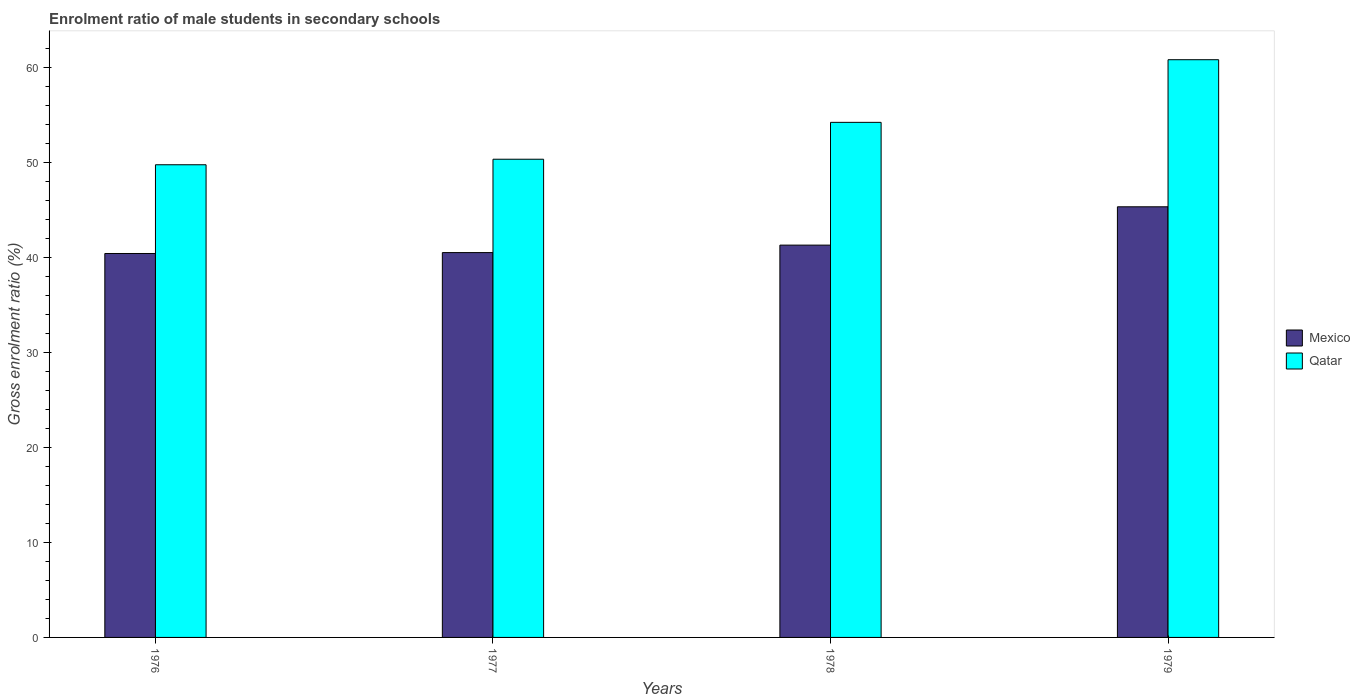How many different coloured bars are there?
Provide a succinct answer. 2. How many groups of bars are there?
Provide a short and direct response. 4. Are the number of bars on each tick of the X-axis equal?
Give a very brief answer. Yes. How many bars are there on the 2nd tick from the left?
Your answer should be very brief. 2. How many bars are there on the 3rd tick from the right?
Offer a terse response. 2. What is the label of the 2nd group of bars from the left?
Give a very brief answer. 1977. In how many cases, is the number of bars for a given year not equal to the number of legend labels?
Provide a succinct answer. 0. What is the enrolment ratio of male students in secondary schools in Qatar in 1976?
Provide a short and direct response. 49.75. Across all years, what is the maximum enrolment ratio of male students in secondary schools in Qatar?
Ensure brevity in your answer.  60.81. Across all years, what is the minimum enrolment ratio of male students in secondary schools in Qatar?
Keep it short and to the point. 49.75. In which year was the enrolment ratio of male students in secondary schools in Mexico maximum?
Ensure brevity in your answer.  1979. In which year was the enrolment ratio of male students in secondary schools in Mexico minimum?
Provide a short and direct response. 1976. What is the total enrolment ratio of male students in secondary schools in Mexico in the graph?
Your response must be concise. 167.54. What is the difference between the enrolment ratio of male students in secondary schools in Qatar in 1976 and that in 1977?
Give a very brief answer. -0.58. What is the difference between the enrolment ratio of male students in secondary schools in Mexico in 1978 and the enrolment ratio of male students in secondary schools in Qatar in 1979?
Make the answer very short. -19.52. What is the average enrolment ratio of male students in secondary schools in Mexico per year?
Offer a very short reply. 41.88. In the year 1979, what is the difference between the enrolment ratio of male students in secondary schools in Mexico and enrolment ratio of male students in secondary schools in Qatar?
Your response must be concise. -15.48. In how many years, is the enrolment ratio of male students in secondary schools in Mexico greater than 40 %?
Offer a terse response. 4. What is the ratio of the enrolment ratio of male students in secondary schools in Qatar in 1978 to that in 1979?
Keep it short and to the point. 0.89. Is the difference between the enrolment ratio of male students in secondary schools in Mexico in 1977 and 1978 greater than the difference between the enrolment ratio of male students in secondary schools in Qatar in 1977 and 1978?
Your answer should be very brief. Yes. What is the difference between the highest and the second highest enrolment ratio of male students in secondary schools in Mexico?
Your response must be concise. 4.03. What is the difference between the highest and the lowest enrolment ratio of male students in secondary schools in Qatar?
Keep it short and to the point. 11.06. What does the 2nd bar from the left in 1976 represents?
Offer a terse response. Qatar. What does the 1st bar from the right in 1979 represents?
Make the answer very short. Qatar. How many bars are there?
Your answer should be compact. 8. Does the graph contain any zero values?
Offer a terse response. No. Does the graph contain grids?
Your answer should be very brief. No. How many legend labels are there?
Keep it short and to the point. 2. What is the title of the graph?
Ensure brevity in your answer.  Enrolment ratio of male students in secondary schools. Does "Sub-Saharan Africa (all income levels)" appear as one of the legend labels in the graph?
Your response must be concise. No. What is the label or title of the X-axis?
Offer a terse response. Years. What is the Gross enrolment ratio (%) of Mexico in 1976?
Make the answer very short. 40.41. What is the Gross enrolment ratio (%) in Qatar in 1976?
Offer a very short reply. 49.75. What is the Gross enrolment ratio (%) in Mexico in 1977?
Make the answer very short. 40.51. What is the Gross enrolment ratio (%) in Qatar in 1977?
Make the answer very short. 50.33. What is the Gross enrolment ratio (%) in Mexico in 1978?
Keep it short and to the point. 41.29. What is the Gross enrolment ratio (%) of Qatar in 1978?
Give a very brief answer. 54.21. What is the Gross enrolment ratio (%) of Mexico in 1979?
Make the answer very short. 45.33. What is the Gross enrolment ratio (%) in Qatar in 1979?
Your response must be concise. 60.81. Across all years, what is the maximum Gross enrolment ratio (%) in Mexico?
Your response must be concise. 45.33. Across all years, what is the maximum Gross enrolment ratio (%) of Qatar?
Your answer should be compact. 60.81. Across all years, what is the minimum Gross enrolment ratio (%) of Mexico?
Provide a short and direct response. 40.41. Across all years, what is the minimum Gross enrolment ratio (%) in Qatar?
Provide a succinct answer. 49.75. What is the total Gross enrolment ratio (%) in Mexico in the graph?
Keep it short and to the point. 167.54. What is the total Gross enrolment ratio (%) in Qatar in the graph?
Make the answer very short. 215.11. What is the difference between the Gross enrolment ratio (%) in Mexico in 1976 and that in 1977?
Keep it short and to the point. -0.09. What is the difference between the Gross enrolment ratio (%) in Qatar in 1976 and that in 1977?
Give a very brief answer. -0.58. What is the difference between the Gross enrolment ratio (%) of Mexico in 1976 and that in 1978?
Your response must be concise. -0.88. What is the difference between the Gross enrolment ratio (%) of Qatar in 1976 and that in 1978?
Keep it short and to the point. -4.46. What is the difference between the Gross enrolment ratio (%) in Mexico in 1976 and that in 1979?
Offer a terse response. -4.91. What is the difference between the Gross enrolment ratio (%) in Qatar in 1976 and that in 1979?
Keep it short and to the point. -11.06. What is the difference between the Gross enrolment ratio (%) of Mexico in 1977 and that in 1978?
Offer a terse response. -0.79. What is the difference between the Gross enrolment ratio (%) in Qatar in 1977 and that in 1978?
Your answer should be very brief. -3.88. What is the difference between the Gross enrolment ratio (%) of Mexico in 1977 and that in 1979?
Give a very brief answer. -4.82. What is the difference between the Gross enrolment ratio (%) of Qatar in 1977 and that in 1979?
Make the answer very short. -10.47. What is the difference between the Gross enrolment ratio (%) of Mexico in 1978 and that in 1979?
Ensure brevity in your answer.  -4.03. What is the difference between the Gross enrolment ratio (%) in Qatar in 1978 and that in 1979?
Give a very brief answer. -6.59. What is the difference between the Gross enrolment ratio (%) of Mexico in 1976 and the Gross enrolment ratio (%) of Qatar in 1977?
Offer a very short reply. -9.92. What is the difference between the Gross enrolment ratio (%) of Mexico in 1976 and the Gross enrolment ratio (%) of Qatar in 1978?
Your answer should be compact. -13.8. What is the difference between the Gross enrolment ratio (%) in Mexico in 1976 and the Gross enrolment ratio (%) in Qatar in 1979?
Keep it short and to the point. -20.4. What is the difference between the Gross enrolment ratio (%) in Mexico in 1977 and the Gross enrolment ratio (%) in Qatar in 1978?
Provide a short and direct response. -13.71. What is the difference between the Gross enrolment ratio (%) of Mexico in 1977 and the Gross enrolment ratio (%) of Qatar in 1979?
Give a very brief answer. -20.3. What is the difference between the Gross enrolment ratio (%) in Mexico in 1978 and the Gross enrolment ratio (%) in Qatar in 1979?
Provide a short and direct response. -19.52. What is the average Gross enrolment ratio (%) in Mexico per year?
Your answer should be very brief. 41.88. What is the average Gross enrolment ratio (%) in Qatar per year?
Provide a succinct answer. 53.78. In the year 1976, what is the difference between the Gross enrolment ratio (%) in Mexico and Gross enrolment ratio (%) in Qatar?
Ensure brevity in your answer.  -9.34. In the year 1977, what is the difference between the Gross enrolment ratio (%) in Mexico and Gross enrolment ratio (%) in Qatar?
Make the answer very short. -9.83. In the year 1978, what is the difference between the Gross enrolment ratio (%) of Mexico and Gross enrolment ratio (%) of Qatar?
Make the answer very short. -12.92. In the year 1979, what is the difference between the Gross enrolment ratio (%) in Mexico and Gross enrolment ratio (%) in Qatar?
Make the answer very short. -15.48. What is the ratio of the Gross enrolment ratio (%) of Qatar in 1976 to that in 1977?
Keep it short and to the point. 0.99. What is the ratio of the Gross enrolment ratio (%) in Mexico in 1976 to that in 1978?
Provide a succinct answer. 0.98. What is the ratio of the Gross enrolment ratio (%) in Qatar in 1976 to that in 1978?
Keep it short and to the point. 0.92. What is the ratio of the Gross enrolment ratio (%) of Mexico in 1976 to that in 1979?
Offer a terse response. 0.89. What is the ratio of the Gross enrolment ratio (%) in Qatar in 1976 to that in 1979?
Ensure brevity in your answer.  0.82. What is the ratio of the Gross enrolment ratio (%) in Mexico in 1977 to that in 1978?
Keep it short and to the point. 0.98. What is the ratio of the Gross enrolment ratio (%) of Qatar in 1977 to that in 1978?
Your response must be concise. 0.93. What is the ratio of the Gross enrolment ratio (%) in Mexico in 1977 to that in 1979?
Your answer should be compact. 0.89. What is the ratio of the Gross enrolment ratio (%) of Qatar in 1977 to that in 1979?
Provide a succinct answer. 0.83. What is the ratio of the Gross enrolment ratio (%) in Mexico in 1978 to that in 1979?
Provide a short and direct response. 0.91. What is the ratio of the Gross enrolment ratio (%) of Qatar in 1978 to that in 1979?
Give a very brief answer. 0.89. What is the difference between the highest and the second highest Gross enrolment ratio (%) in Mexico?
Keep it short and to the point. 4.03. What is the difference between the highest and the second highest Gross enrolment ratio (%) of Qatar?
Your answer should be very brief. 6.59. What is the difference between the highest and the lowest Gross enrolment ratio (%) in Mexico?
Your response must be concise. 4.91. What is the difference between the highest and the lowest Gross enrolment ratio (%) of Qatar?
Your response must be concise. 11.06. 